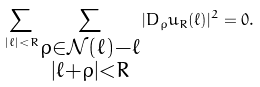<formula> <loc_0><loc_0><loc_500><loc_500>\sum _ { | \ell | < R } \sum _ { \substack { \rho \in \mathcal { N } ( \ell ) - \ell \\ | \ell + \rho | < R } } | D _ { \rho } u _ { R } ( \ell ) | ^ { 2 } = 0 .</formula> 